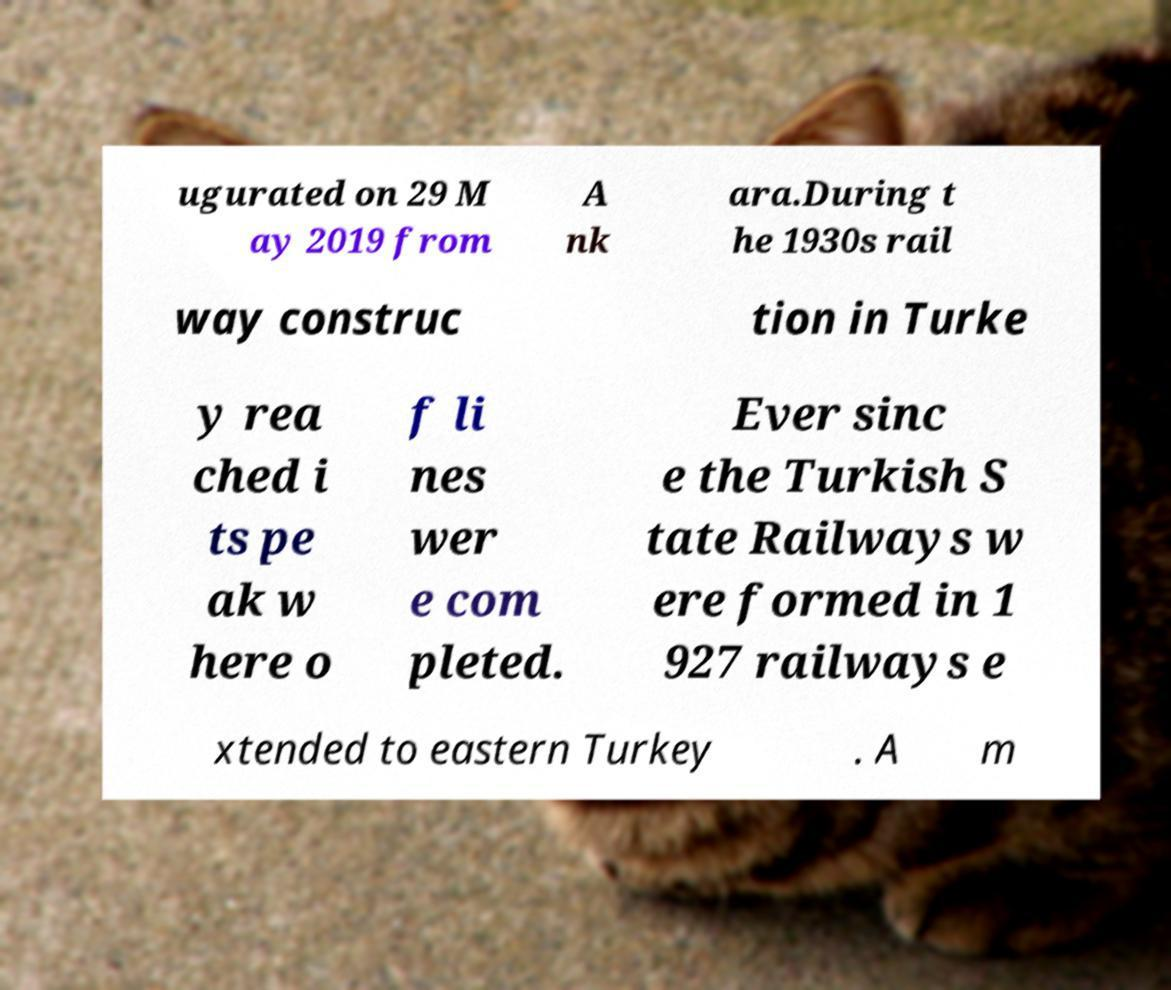For documentation purposes, I need the text within this image transcribed. Could you provide that? ugurated on 29 M ay 2019 from A nk ara.During t he 1930s rail way construc tion in Turke y rea ched i ts pe ak w here o f li nes wer e com pleted. Ever sinc e the Turkish S tate Railways w ere formed in 1 927 railways e xtended to eastern Turkey . A m 